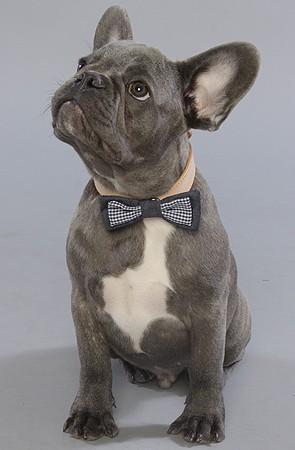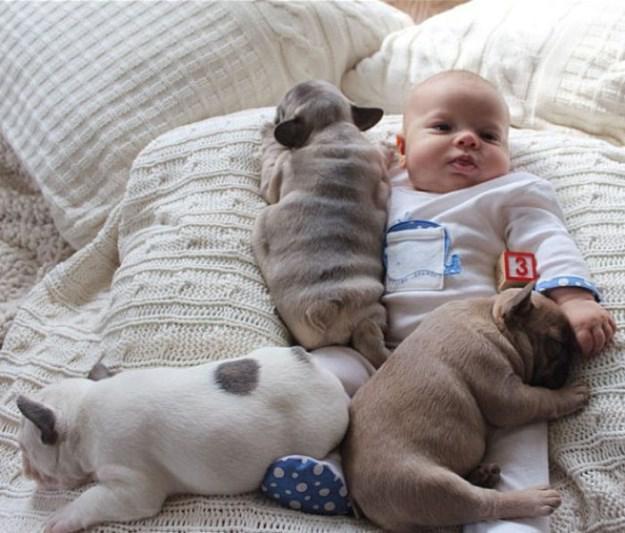The first image is the image on the left, the second image is the image on the right. Examine the images to the left and right. Is the description "At least one dog is sleeping next to a human." accurate? Answer yes or no. Yes. The first image is the image on the left, the second image is the image on the right. Considering the images on both sides, is "An adult human is holding one of the dogs." valid? Answer yes or no. No. 